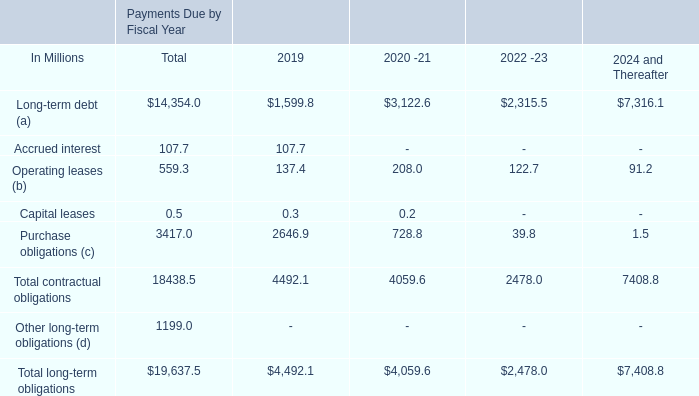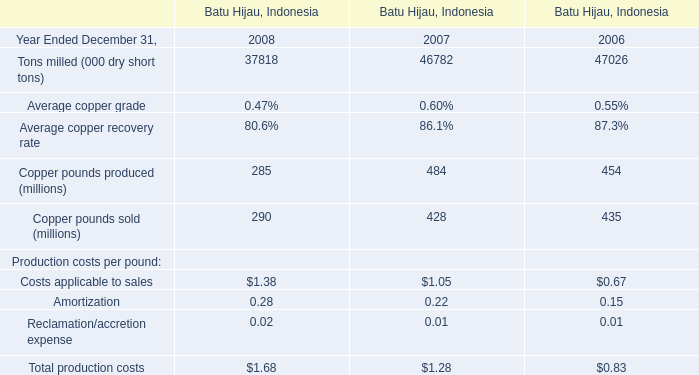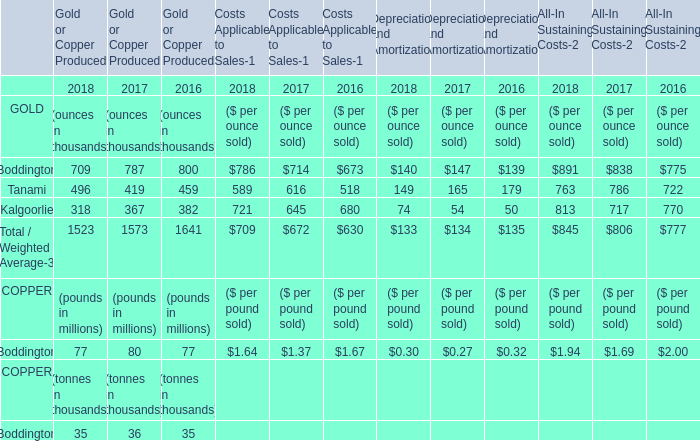What is the ratio of GOLD in terms of Boddington to the Total GOLD in 2018,for Gold or Copper Produced? 
Computations: (709 / 1523)
Answer: 0.46553. 